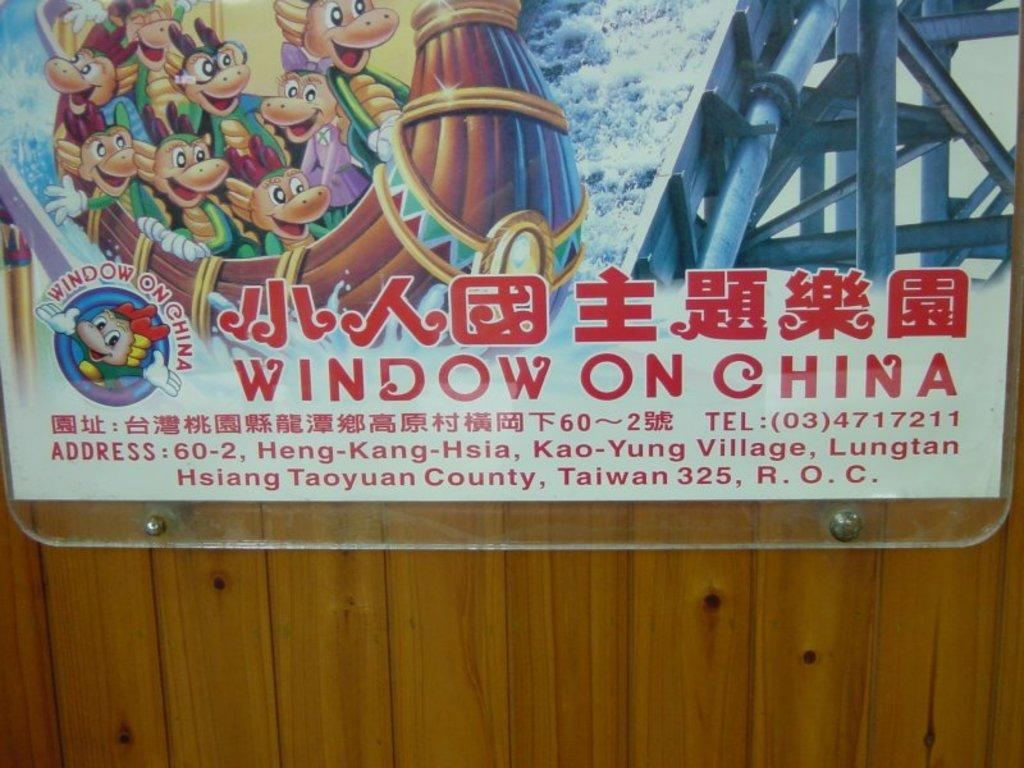<image>
Summarize the visual content of the image. A poster hung on a wall advertises Window On China 